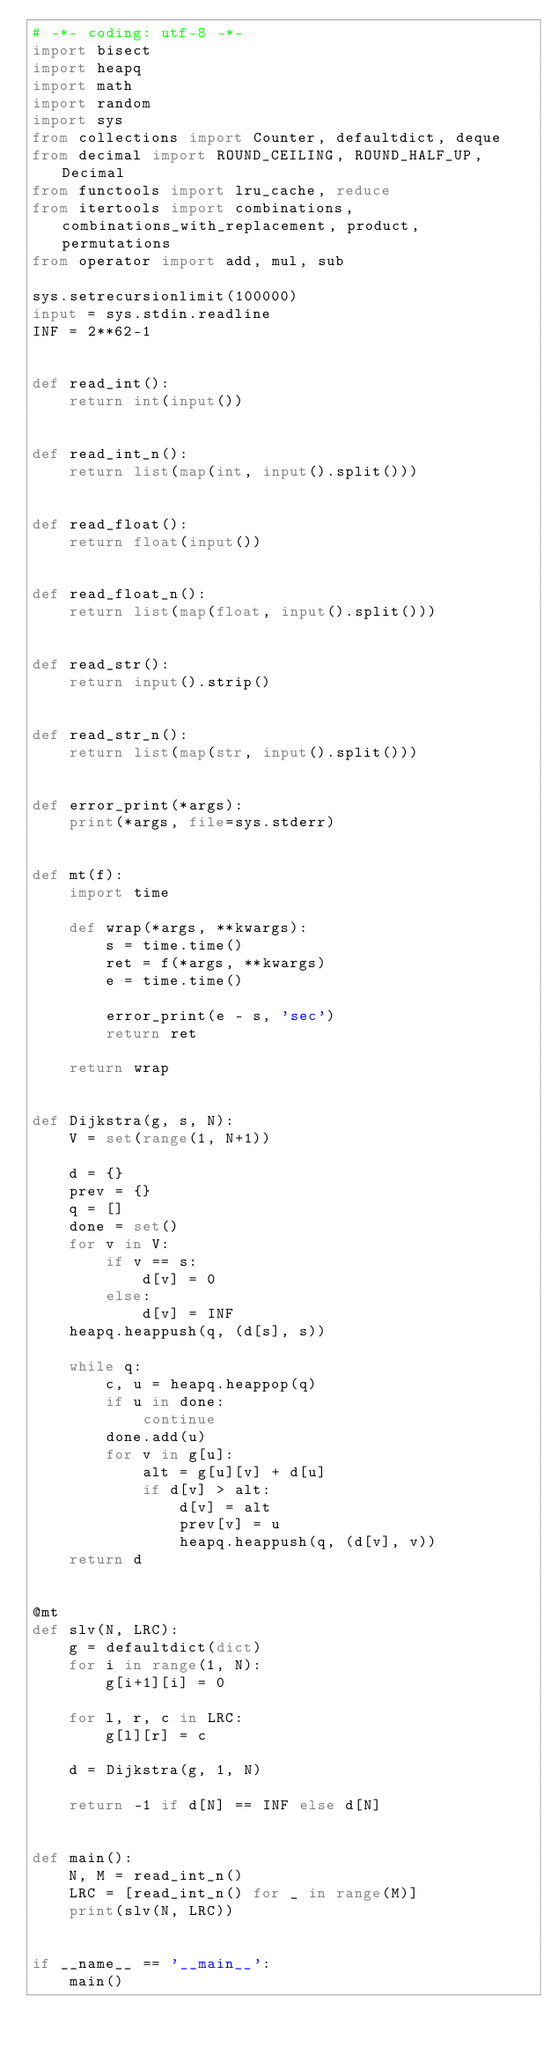Convert code to text. <code><loc_0><loc_0><loc_500><loc_500><_Python_># -*- coding: utf-8 -*-
import bisect
import heapq
import math
import random
import sys
from collections import Counter, defaultdict, deque
from decimal import ROUND_CEILING, ROUND_HALF_UP, Decimal
from functools import lru_cache, reduce
from itertools import combinations, combinations_with_replacement, product, permutations
from operator import add, mul, sub

sys.setrecursionlimit(100000)
input = sys.stdin.readline
INF = 2**62-1


def read_int():
    return int(input())


def read_int_n():
    return list(map(int, input().split()))


def read_float():
    return float(input())


def read_float_n():
    return list(map(float, input().split()))


def read_str():
    return input().strip()


def read_str_n():
    return list(map(str, input().split()))


def error_print(*args):
    print(*args, file=sys.stderr)


def mt(f):
    import time

    def wrap(*args, **kwargs):
        s = time.time()
        ret = f(*args, **kwargs)
        e = time.time()

        error_print(e - s, 'sec')
        return ret

    return wrap


def Dijkstra(g, s, N):
    V = set(range(1, N+1))

    d = {}
    prev = {}
    q = []
    done = set()
    for v in V:
        if v == s:
            d[v] = 0
        else:
            d[v] = INF
    heapq.heappush(q, (d[s], s))

    while q:
        c, u = heapq.heappop(q)
        if u in done:
            continue
        done.add(u)
        for v in g[u]:
            alt = g[u][v] + d[u]
            if d[v] > alt:
                d[v] = alt
                prev[v] = u
                heapq.heappush(q, (d[v], v))
    return d


@mt
def slv(N, LRC):
    g = defaultdict(dict)
    for i in range(1, N):
        g[i+1][i] = 0

    for l, r, c in LRC:
        g[l][r] = c
    
    d = Dijkstra(g, 1, N)

    return -1 if d[N] == INF else d[N]


def main():
    N, M = read_int_n()
    LRC = [read_int_n() for _ in range(M)]
    print(slv(N, LRC))


if __name__ == '__main__':
    main()
</code> 